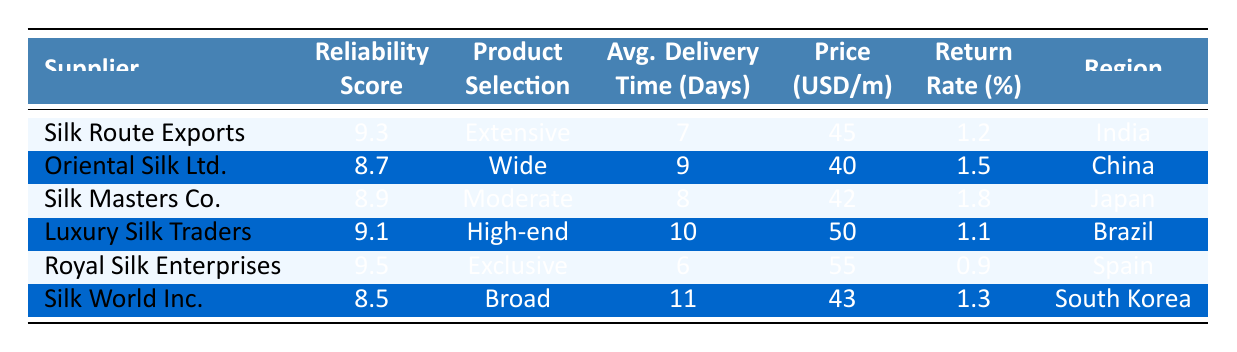What is the reliability score of Royal Silk Enterprises? According to the table, Royal Silk Enterprises has a reliability score listed in the corresponding row. That score is 9.5.
Answer: 9.5 Which supplier has the shortest average delivery time? The average delivery times for each supplier are compared. The shortest delivery time is 6 days for Royal Silk Enterprises.
Answer: 6 days What is the product selection of Oriental Silk Ltd.? For Oriental Silk Ltd., looking at the product selection column, it is specified as "Wide."
Answer: Wide Is the return rate for Silk Route Exports higher than 1 percent? The return rate for Silk Route Exports is listed as 1.2 percent, which is indeed higher than 1 percent.
Answer: Yes What is the average price per meter among all suppliers? To find the average price per meter, add together the prices: 45, 40, 42, 50, 55, and 43, which sums to 275. There are 6 suppliers, so the average is 275 divided by 6, yielding approximately 45.83.
Answer: 45.83 Which supplier offers the highest reliability score with low return rates? Royal Silk Enterprises has the highest reliability score of 9.5 and the lowest return rate of 0.9. The combination makes it the best option for reliability and returns.
Answer: Royal Silk Enterprises Are there any suppliers from the region of South Korea? By checking the region column, Silk World Inc. is confirmed to be from South Korea, making the answer yes.
Answer: Yes Which supplier has the highest price per meter, and what is that price? Reviewing the price column, Luxury Silk Traders has the highest price listed at 50 USD per meter.
Answer: 50 USD What is the difference in reliability score between Silk Route Exports and Silk Masters Co.? The reliability score for Silk Route Exports is 9.3, while for Silk Masters Co., it is 8.9. The difference is calculated as 9.3 - 8.9, which equals 0.4.
Answer: 0.4 